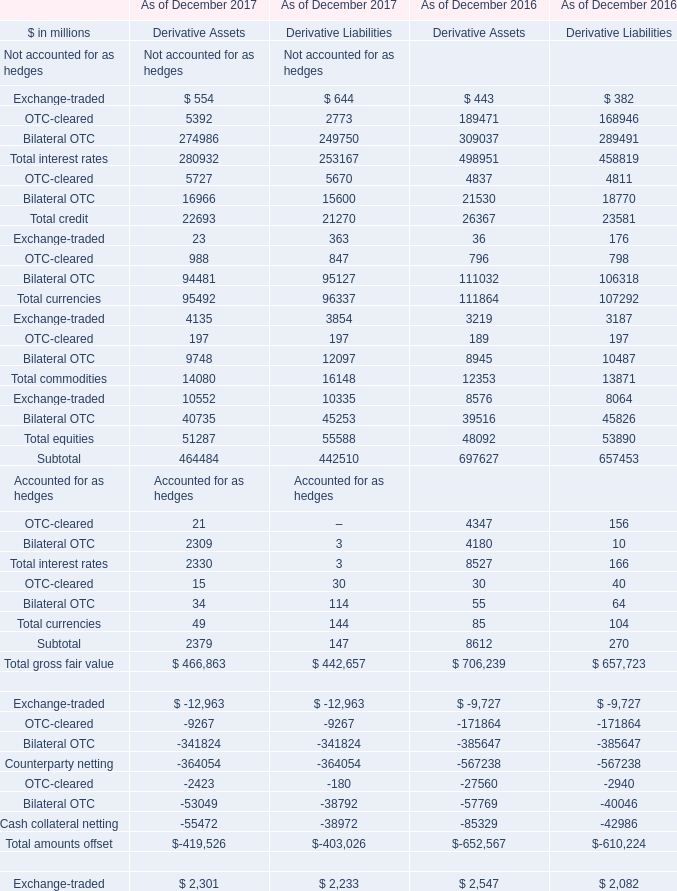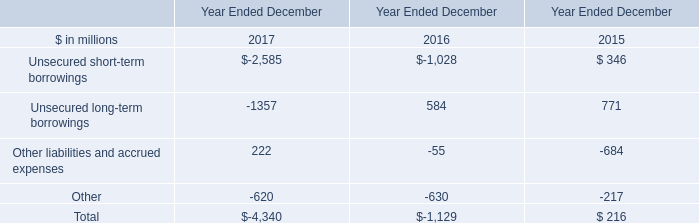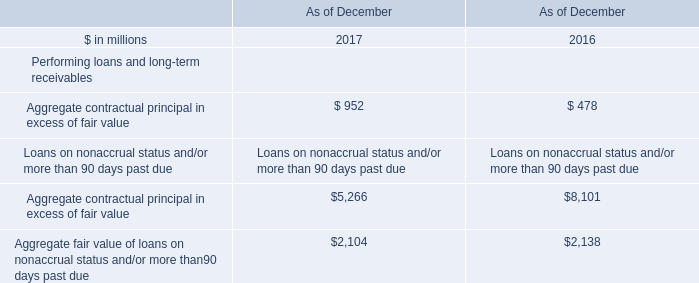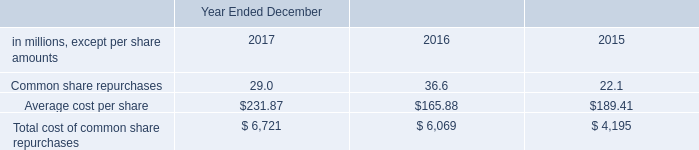what was the percentage change in dividends declared per common share between 2016 and 2017? 
Computations: ((2.90 - 2.60) / 2.60)
Answer: 0.11538. 